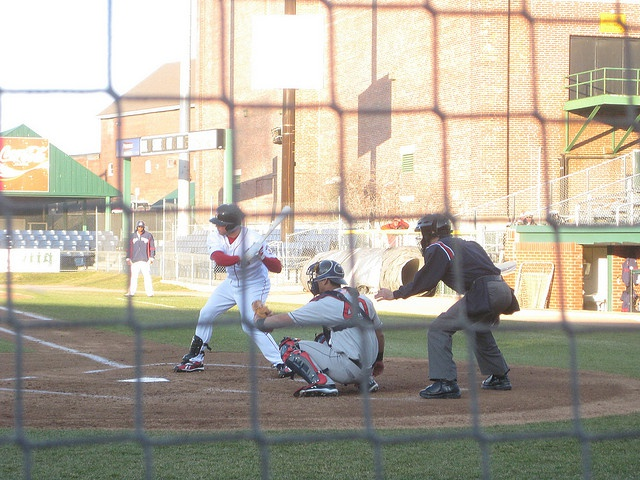Describe the objects in this image and their specific colors. I can see people in white, gray, and black tones, people in white, gray, and darkgray tones, people in white, lavender, gray, lightblue, and darkgray tones, people in white, darkgray, khaki, and lightpink tones, and baseball glove in white, gray, darkgray, and tan tones in this image. 